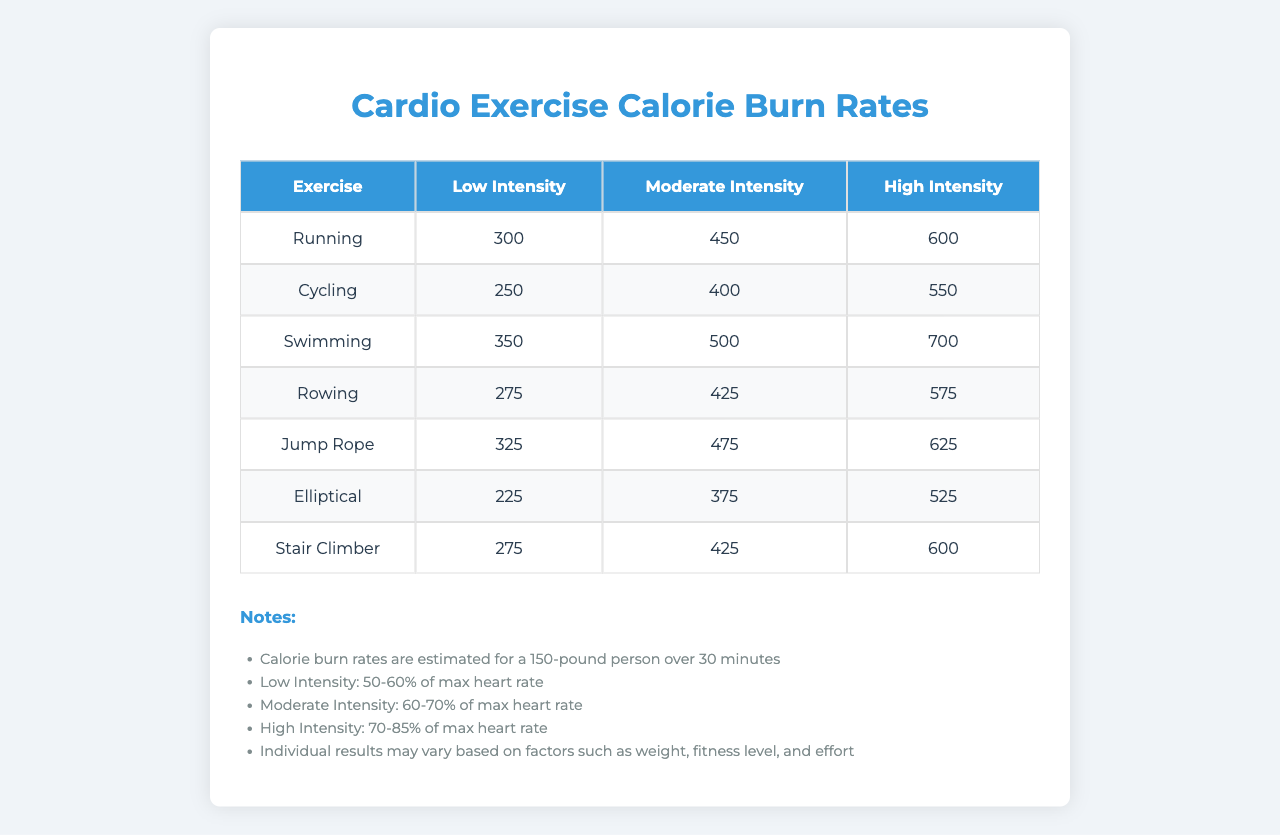What is the calorie burn rate for high-intensity running? The table shows that the calorie burn rate for high-intensity running is 600 calories.
Answer: 600 Which exercise has the highest calorie burn rate at low intensity? By comparing the low-intensity calories, swimming at 350 calories has the highest rate among the exercises listed.
Answer: 350 What is the average calorie burn rate for moderate intensity across all exercises? Adding the moderate intensity values: 450 (running) + 400 (cycling) + 500 (swimming) + 425 (rowing) + 475 (jump rope) + 375 (elliptical) + 425 (stair climber) = 3250. Dividing by 7 (the number of exercises), the average is 461.43.
Answer: 461.43 Which exercise has the lowest calorie burn rate in the moderate intensity category? Among the moderate intensity values, cycling has the lowest calorie burn rate at 400 calories.
Answer: 400 Is the calorie burn rate for rowing at high intensity higher than that for cycling at low intensity? The calorie burn rate for rowing at high intensity is 575 calories, while cycling at low intensity has a calorie burn rate of 250 calories. 575 > 250 means yes, it's higher.
Answer: Yes What is the difference in calorie burn rate between high intensity and low intensity for jump rope? The high intensity for jump rope is 625 calories and low intensity is 325 calories. The difference is 625 - 325 = 300.
Answer: 300 If a person chooses swimming at moderate intensity and running at low intensity, how many calories will they burn in total? The calorie burn for swimming at moderate intensity is 500 calories and for running at low intensity, it is 300 calories. Adding these gives 500 + 300 = 800 calories.
Answer: 800 Which cardio exercise burned 575 calories at high intensity? The high-intensity calorie burn rate for rowing matches 575 calories.
Answer: Rowing How many calories does the elliptical machine burn at moderate intensity? According to the table, the elliptical machine burns 375 calories at moderate intensity.
Answer: 375 Is it true that cycling has a higher calorie burn rate at high intensity than rowing at moderate intensity? The high intensity for cycling is 550 calories, and for rowing at moderate intensity, it is 425 calories. Since 550 > 425, this statement is true.
Answer: True 